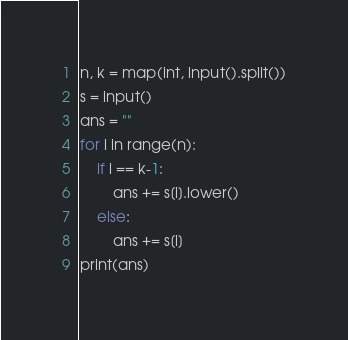Convert code to text. <code><loc_0><loc_0><loc_500><loc_500><_Python_>n, k = map(int, input().split())
s = input()
ans = ""
for i in range(n):
    if i == k-1:
        ans += s[i].lower()
    else:
        ans += s[i]
print(ans)</code> 